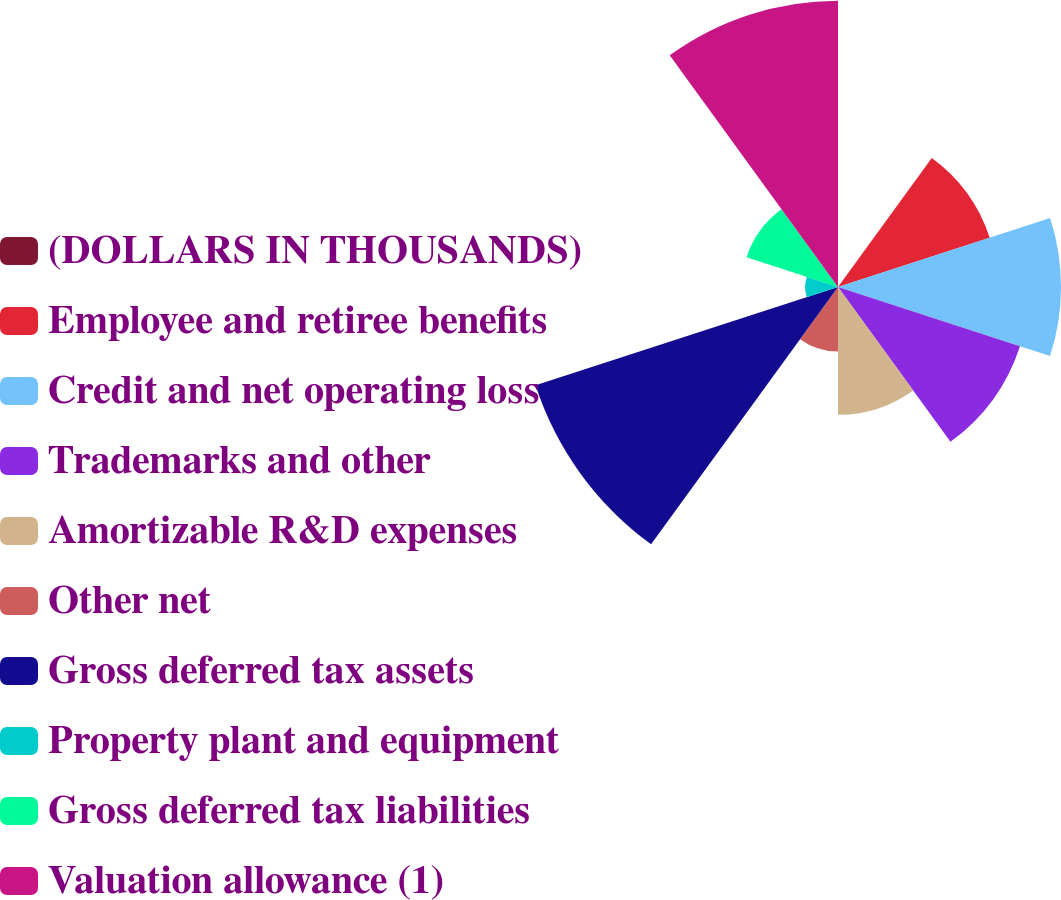<chart> <loc_0><loc_0><loc_500><loc_500><pie_chart><fcel>(DOLLARS IN THOUSANDS)<fcel>Employee and retiree benefits<fcel>Credit and net operating loss<fcel>Trademarks and other<fcel>Amortizable R&D expenses<fcel>Other net<fcel>Gross deferred tax assets<fcel>Property plant and equipment<fcel>Gross deferred tax liabilities<fcel>Valuation allowance (1)<nl><fcel>0.07%<fcel>10.63%<fcel>14.86%<fcel>12.75%<fcel>8.52%<fcel>4.3%<fcel>21.19%<fcel>2.19%<fcel>6.41%<fcel>19.08%<nl></chart> 